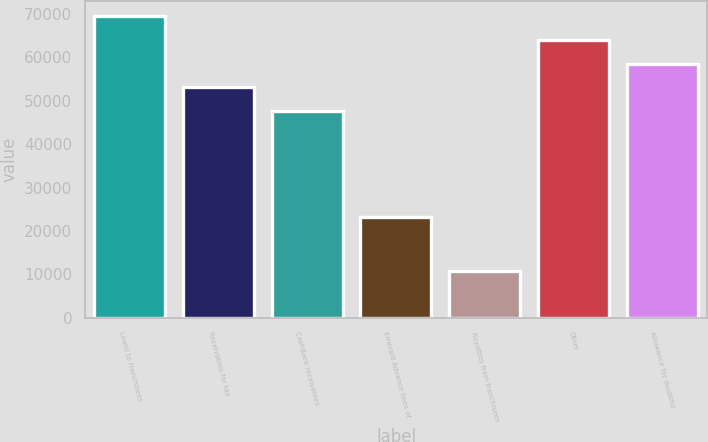Convert chart to OTSL. <chart><loc_0><loc_0><loc_500><loc_500><bar_chart><fcel>Loans to franchisees<fcel>Receivables for tax<fcel>CashBack receivables<fcel>Emerald Advance lines of<fcel>Royalties from franchisees<fcel>Other<fcel>Allowance for doubtful<nl><fcel>69534.4<fcel>53127.1<fcel>47658<fcel>23218<fcel>10722<fcel>64065.3<fcel>58596.2<nl></chart> 